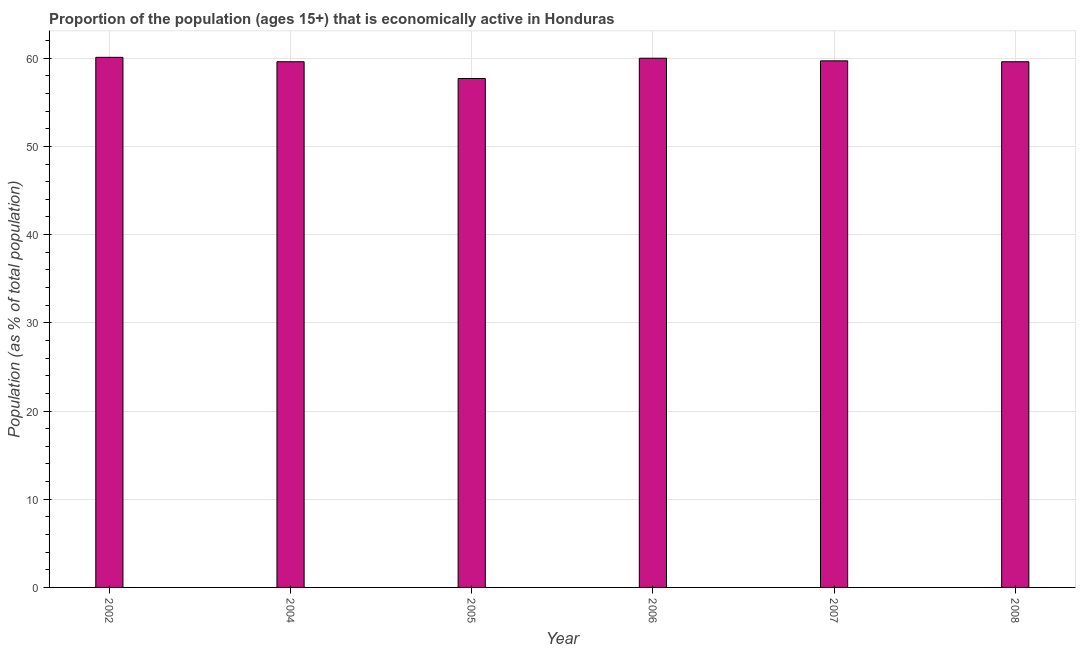Does the graph contain grids?
Give a very brief answer. Yes. What is the title of the graph?
Keep it short and to the point. Proportion of the population (ages 15+) that is economically active in Honduras. What is the label or title of the Y-axis?
Offer a very short reply. Population (as % of total population). What is the percentage of economically active population in 2004?
Ensure brevity in your answer.  59.6. Across all years, what is the maximum percentage of economically active population?
Offer a very short reply. 60.1. Across all years, what is the minimum percentage of economically active population?
Provide a short and direct response. 57.7. What is the sum of the percentage of economically active population?
Provide a succinct answer. 356.7. What is the difference between the percentage of economically active population in 2002 and 2006?
Keep it short and to the point. 0.1. What is the average percentage of economically active population per year?
Keep it short and to the point. 59.45. What is the median percentage of economically active population?
Offer a terse response. 59.65. In how many years, is the percentage of economically active population greater than 18 %?
Ensure brevity in your answer.  6. What is the ratio of the percentage of economically active population in 2004 to that in 2005?
Your answer should be very brief. 1.03. In how many years, is the percentage of economically active population greater than the average percentage of economically active population taken over all years?
Ensure brevity in your answer.  5. How many bars are there?
Your response must be concise. 6. What is the difference between two consecutive major ticks on the Y-axis?
Your response must be concise. 10. What is the Population (as % of total population) of 2002?
Ensure brevity in your answer.  60.1. What is the Population (as % of total population) of 2004?
Ensure brevity in your answer.  59.6. What is the Population (as % of total population) in 2005?
Your response must be concise. 57.7. What is the Population (as % of total population) in 2006?
Your answer should be very brief. 60. What is the Population (as % of total population) in 2007?
Provide a succinct answer. 59.7. What is the Population (as % of total population) of 2008?
Offer a terse response. 59.6. What is the difference between the Population (as % of total population) in 2004 and 2005?
Ensure brevity in your answer.  1.9. What is the difference between the Population (as % of total population) in 2004 and 2007?
Your answer should be very brief. -0.1. What is the difference between the Population (as % of total population) in 2005 and 2006?
Keep it short and to the point. -2.3. What is the ratio of the Population (as % of total population) in 2002 to that in 2005?
Keep it short and to the point. 1.04. What is the ratio of the Population (as % of total population) in 2004 to that in 2005?
Your answer should be compact. 1.03. What is the ratio of the Population (as % of total population) in 2004 to that in 2008?
Your answer should be very brief. 1. What is the ratio of the Population (as % of total population) in 2005 to that in 2006?
Give a very brief answer. 0.96. What is the ratio of the Population (as % of total population) in 2006 to that in 2007?
Keep it short and to the point. 1. What is the ratio of the Population (as % of total population) in 2006 to that in 2008?
Offer a terse response. 1.01. What is the ratio of the Population (as % of total population) in 2007 to that in 2008?
Provide a short and direct response. 1. 